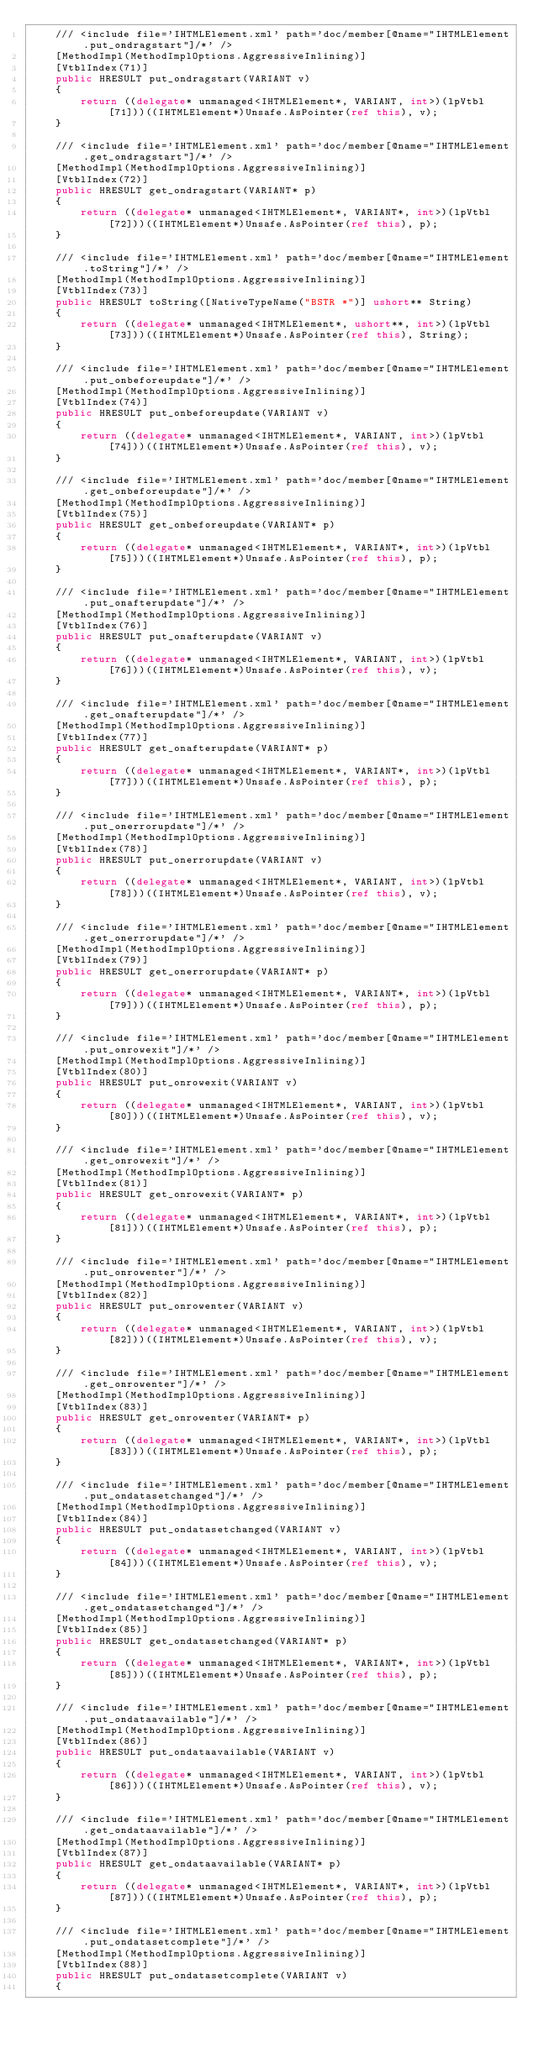Convert code to text. <code><loc_0><loc_0><loc_500><loc_500><_C#_>    /// <include file='IHTMLElement.xml' path='doc/member[@name="IHTMLElement.put_ondragstart"]/*' />
    [MethodImpl(MethodImplOptions.AggressiveInlining)]
    [VtblIndex(71)]
    public HRESULT put_ondragstart(VARIANT v)
    {
        return ((delegate* unmanaged<IHTMLElement*, VARIANT, int>)(lpVtbl[71]))((IHTMLElement*)Unsafe.AsPointer(ref this), v);
    }

    /// <include file='IHTMLElement.xml' path='doc/member[@name="IHTMLElement.get_ondragstart"]/*' />
    [MethodImpl(MethodImplOptions.AggressiveInlining)]
    [VtblIndex(72)]
    public HRESULT get_ondragstart(VARIANT* p)
    {
        return ((delegate* unmanaged<IHTMLElement*, VARIANT*, int>)(lpVtbl[72]))((IHTMLElement*)Unsafe.AsPointer(ref this), p);
    }

    /// <include file='IHTMLElement.xml' path='doc/member[@name="IHTMLElement.toString"]/*' />
    [MethodImpl(MethodImplOptions.AggressiveInlining)]
    [VtblIndex(73)]
    public HRESULT toString([NativeTypeName("BSTR *")] ushort** String)
    {
        return ((delegate* unmanaged<IHTMLElement*, ushort**, int>)(lpVtbl[73]))((IHTMLElement*)Unsafe.AsPointer(ref this), String);
    }

    /// <include file='IHTMLElement.xml' path='doc/member[@name="IHTMLElement.put_onbeforeupdate"]/*' />
    [MethodImpl(MethodImplOptions.AggressiveInlining)]
    [VtblIndex(74)]
    public HRESULT put_onbeforeupdate(VARIANT v)
    {
        return ((delegate* unmanaged<IHTMLElement*, VARIANT, int>)(lpVtbl[74]))((IHTMLElement*)Unsafe.AsPointer(ref this), v);
    }

    /// <include file='IHTMLElement.xml' path='doc/member[@name="IHTMLElement.get_onbeforeupdate"]/*' />
    [MethodImpl(MethodImplOptions.AggressiveInlining)]
    [VtblIndex(75)]
    public HRESULT get_onbeforeupdate(VARIANT* p)
    {
        return ((delegate* unmanaged<IHTMLElement*, VARIANT*, int>)(lpVtbl[75]))((IHTMLElement*)Unsafe.AsPointer(ref this), p);
    }

    /// <include file='IHTMLElement.xml' path='doc/member[@name="IHTMLElement.put_onafterupdate"]/*' />
    [MethodImpl(MethodImplOptions.AggressiveInlining)]
    [VtblIndex(76)]
    public HRESULT put_onafterupdate(VARIANT v)
    {
        return ((delegate* unmanaged<IHTMLElement*, VARIANT, int>)(lpVtbl[76]))((IHTMLElement*)Unsafe.AsPointer(ref this), v);
    }

    /// <include file='IHTMLElement.xml' path='doc/member[@name="IHTMLElement.get_onafterupdate"]/*' />
    [MethodImpl(MethodImplOptions.AggressiveInlining)]
    [VtblIndex(77)]
    public HRESULT get_onafterupdate(VARIANT* p)
    {
        return ((delegate* unmanaged<IHTMLElement*, VARIANT*, int>)(lpVtbl[77]))((IHTMLElement*)Unsafe.AsPointer(ref this), p);
    }

    /// <include file='IHTMLElement.xml' path='doc/member[@name="IHTMLElement.put_onerrorupdate"]/*' />
    [MethodImpl(MethodImplOptions.AggressiveInlining)]
    [VtblIndex(78)]
    public HRESULT put_onerrorupdate(VARIANT v)
    {
        return ((delegate* unmanaged<IHTMLElement*, VARIANT, int>)(lpVtbl[78]))((IHTMLElement*)Unsafe.AsPointer(ref this), v);
    }

    /// <include file='IHTMLElement.xml' path='doc/member[@name="IHTMLElement.get_onerrorupdate"]/*' />
    [MethodImpl(MethodImplOptions.AggressiveInlining)]
    [VtblIndex(79)]
    public HRESULT get_onerrorupdate(VARIANT* p)
    {
        return ((delegate* unmanaged<IHTMLElement*, VARIANT*, int>)(lpVtbl[79]))((IHTMLElement*)Unsafe.AsPointer(ref this), p);
    }

    /// <include file='IHTMLElement.xml' path='doc/member[@name="IHTMLElement.put_onrowexit"]/*' />
    [MethodImpl(MethodImplOptions.AggressiveInlining)]
    [VtblIndex(80)]
    public HRESULT put_onrowexit(VARIANT v)
    {
        return ((delegate* unmanaged<IHTMLElement*, VARIANT, int>)(lpVtbl[80]))((IHTMLElement*)Unsafe.AsPointer(ref this), v);
    }

    /// <include file='IHTMLElement.xml' path='doc/member[@name="IHTMLElement.get_onrowexit"]/*' />
    [MethodImpl(MethodImplOptions.AggressiveInlining)]
    [VtblIndex(81)]
    public HRESULT get_onrowexit(VARIANT* p)
    {
        return ((delegate* unmanaged<IHTMLElement*, VARIANT*, int>)(lpVtbl[81]))((IHTMLElement*)Unsafe.AsPointer(ref this), p);
    }

    /// <include file='IHTMLElement.xml' path='doc/member[@name="IHTMLElement.put_onrowenter"]/*' />
    [MethodImpl(MethodImplOptions.AggressiveInlining)]
    [VtblIndex(82)]
    public HRESULT put_onrowenter(VARIANT v)
    {
        return ((delegate* unmanaged<IHTMLElement*, VARIANT, int>)(lpVtbl[82]))((IHTMLElement*)Unsafe.AsPointer(ref this), v);
    }

    /// <include file='IHTMLElement.xml' path='doc/member[@name="IHTMLElement.get_onrowenter"]/*' />
    [MethodImpl(MethodImplOptions.AggressiveInlining)]
    [VtblIndex(83)]
    public HRESULT get_onrowenter(VARIANT* p)
    {
        return ((delegate* unmanaged<IHTMLElement*, VARIANT*, int>)(lpVtbl[83]))((IHTMLElement*)Unsafe.AsPointer(ref this), p);
    }

    /// <include file='IHTMLElement.xml' path='doc/member[@name="IHTMLElement.put_ondatasetchanged"]/*' />
    [MethodImpl(MethodImplOptions.AggressiveInlining)]
    [VtblIndex(84)]
    public HRESULT put_ondatasetchanged(VARIANT v)
    {
        return ((delegate* unmanaged<IHTMLElement*, VARIANT, int>)(lpVtbl[84]))((IHTMLElement*)Unsafe.AsPointer(ref this), v);
    }

    /// <include file='IHTMLElement.xml' path='doc/member[@name="IHTMLElement.get_ondatasetchanged"]/*' />
    [MethodImpl(MethodImplOptions.AggressiveInlining)]
    [VtblIndex(85)]
    public HRESULT get_ondatasetchanged(VARIANT* p)
    {
        return ((delegate* unmanaged<IHTMLElement*, VARIANT*, int>)(lpVtbl[85]))((IHTMLElement*)Unsafe.AsPointer(ref this), p);
    }

    /// <include file='IHTMLElement.xml' path='doc/member[@name="IHTMLElement.put_ondataavailable"]/*' />
    [MethodImpl(MethodImplOptions.AggressiveInlining)]
    [VtblIndex(86)]
    public HRESULT put_ondataavailable(VARIANT v)
    {
        return ((delegate* unmanaged<IHTMLElement*, VARIANT, int>)(lpVtbl[86]))((IHTMLElement*)Unsafe.AsPointer(ref this), v);
    }

    /// <include file='IHTMLElement.xml' path='doc/member[@name="IHTMLElement.get_ondataavailable"]/*' />
    [MethodImpl(MethodImplOptions.AggressiveInlining)]
    [VtblIndex(87)]
    public HRESULT get_ondataavailable(VARIANT* p)
    {
        return ((delegate* unmanaged<IHTMLElement*, VARIANT*, int>)(lpVtbl[87]))((IHTMLElement*)Unsafe.AsPointer(ref this), p);
    }

    /// <include file='IHTMLElement.xml' path='doc/member[@name="IHTMLElement.put_ondatasetcomplete"]/*' />
    [MethodImpl(MethodImplOptions.AggressiveInlining)]
    [VtblIndex(88)]
    public HRESULT put_ondatasetcomplete(VARIANT v)
    {</code> 